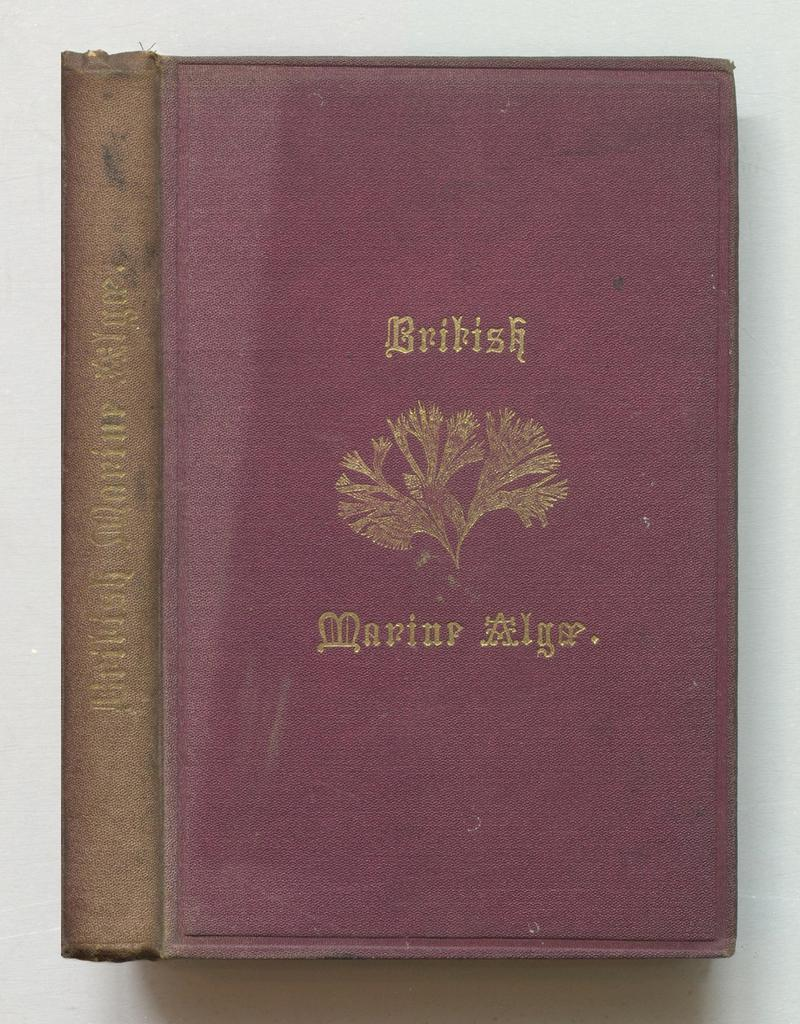<image>
Offer a succinct explanation of the picture presented. An old red book cover titled British Marine Algae. 